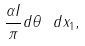Convert formula to latex. <formula><loc_0><loc_0><loc_500><loc_500>\frac { \alpha I } { \pi } d \theta \ d x _ { 1 } ,</formula> 